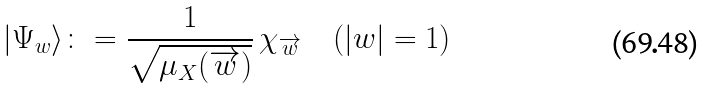Convert formula to latex. <formula><loc_0><loc_0><loc_500><loc_500>| \Psi _ { w } \rangle \colon = \frac { 1 } { \sqrt { \mu _ { X } ( \overrightarrow { w } ) } } \, \chi _ { \overrightarrow { w } } \quad ( | w | = 1 )</formula> 